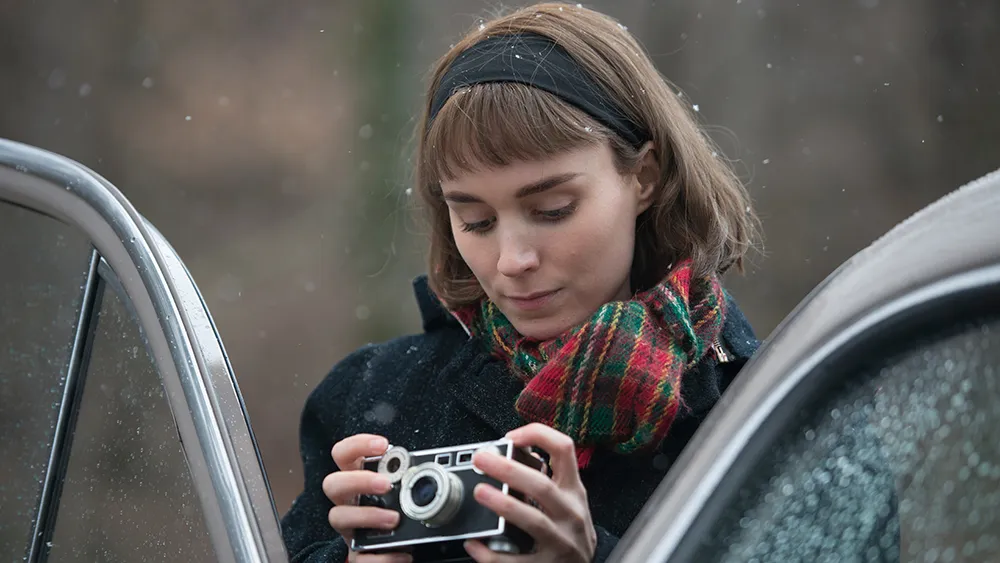What emotions does the image evoke for you? The image evokes a sense of calm and introspection. The woman's focused expression and the peaceful, rain-speckled setting create an atmosphere of quiet contemplation. It feels like a moment of respite and reflection, perhaps inviting the viewer to also take a pause and appreciate the serene beauty of the scene. There's a subtle sense of nostalgia, amplified by the vintage feel of the camera and the natural backdrop, suggesting a connection to past memories or a moment of anticipation for what lies ahead.  If you could step into the image, what would you do or experience there? Stepping into the image, you might experience the soothing ambiance of a serene and rainy day. The air would be cool and fresh with the scent of rain and wet earth. You could hear the gentle patter of raindrops on the car and the soft rustling of leaves in the background. Engaging with the woman, you might discuss the art of photography and share stories captured through the lens. The moment would be filled with calm, allowing you to immerse yourself in nature's tranquility and perhaps gain a new perspective on capturing fleeting, beautiful moments.  Describe a day in the life of the person in this image. A day in the life of the woman in the image might begin with an early morning wake-up, preparing her camera gear for a day's adventure. She'd likely dress warmly, donning her black coat and her colorful plaid scarf, essential for fending off the cool, damp weather. After a hearty breakfast, she'd set off in her trusty vintage car, driving through scenic countryside routes to find the perfect spots for her photography. Her day would involve exploring quiet, picturesque locations, taking thoughtful and artistic photographs, and occasionally stopping to jot down notes or sketches in her notebook. By late afternoon, she'd retreat to a cozy café or return home to review her work, enjoying a warm cup of tea as she reflects on the day's captures. Her evenings might be spent editing photos, planning future projects, or engaging in quiet, personal moments of introspection similar to the one depicted in the image.  What kind of story does the background suggest? The blurred woodland background suggests a story set in a tranquil, rural location, perhaps far from the bustling city life. It hints at themes of nature, serenity, and solitude. The setting could be part of a narrative where the protagonist seeks peace and inspiration from the natural world. It could also imply a journey or a retreat, where the character finds solace and clarity amidst the trees and the rain. The woodland setting serves as a backdrop for moments of personal reflection and connection to the environment, adding depth and a serene mood to the story. 